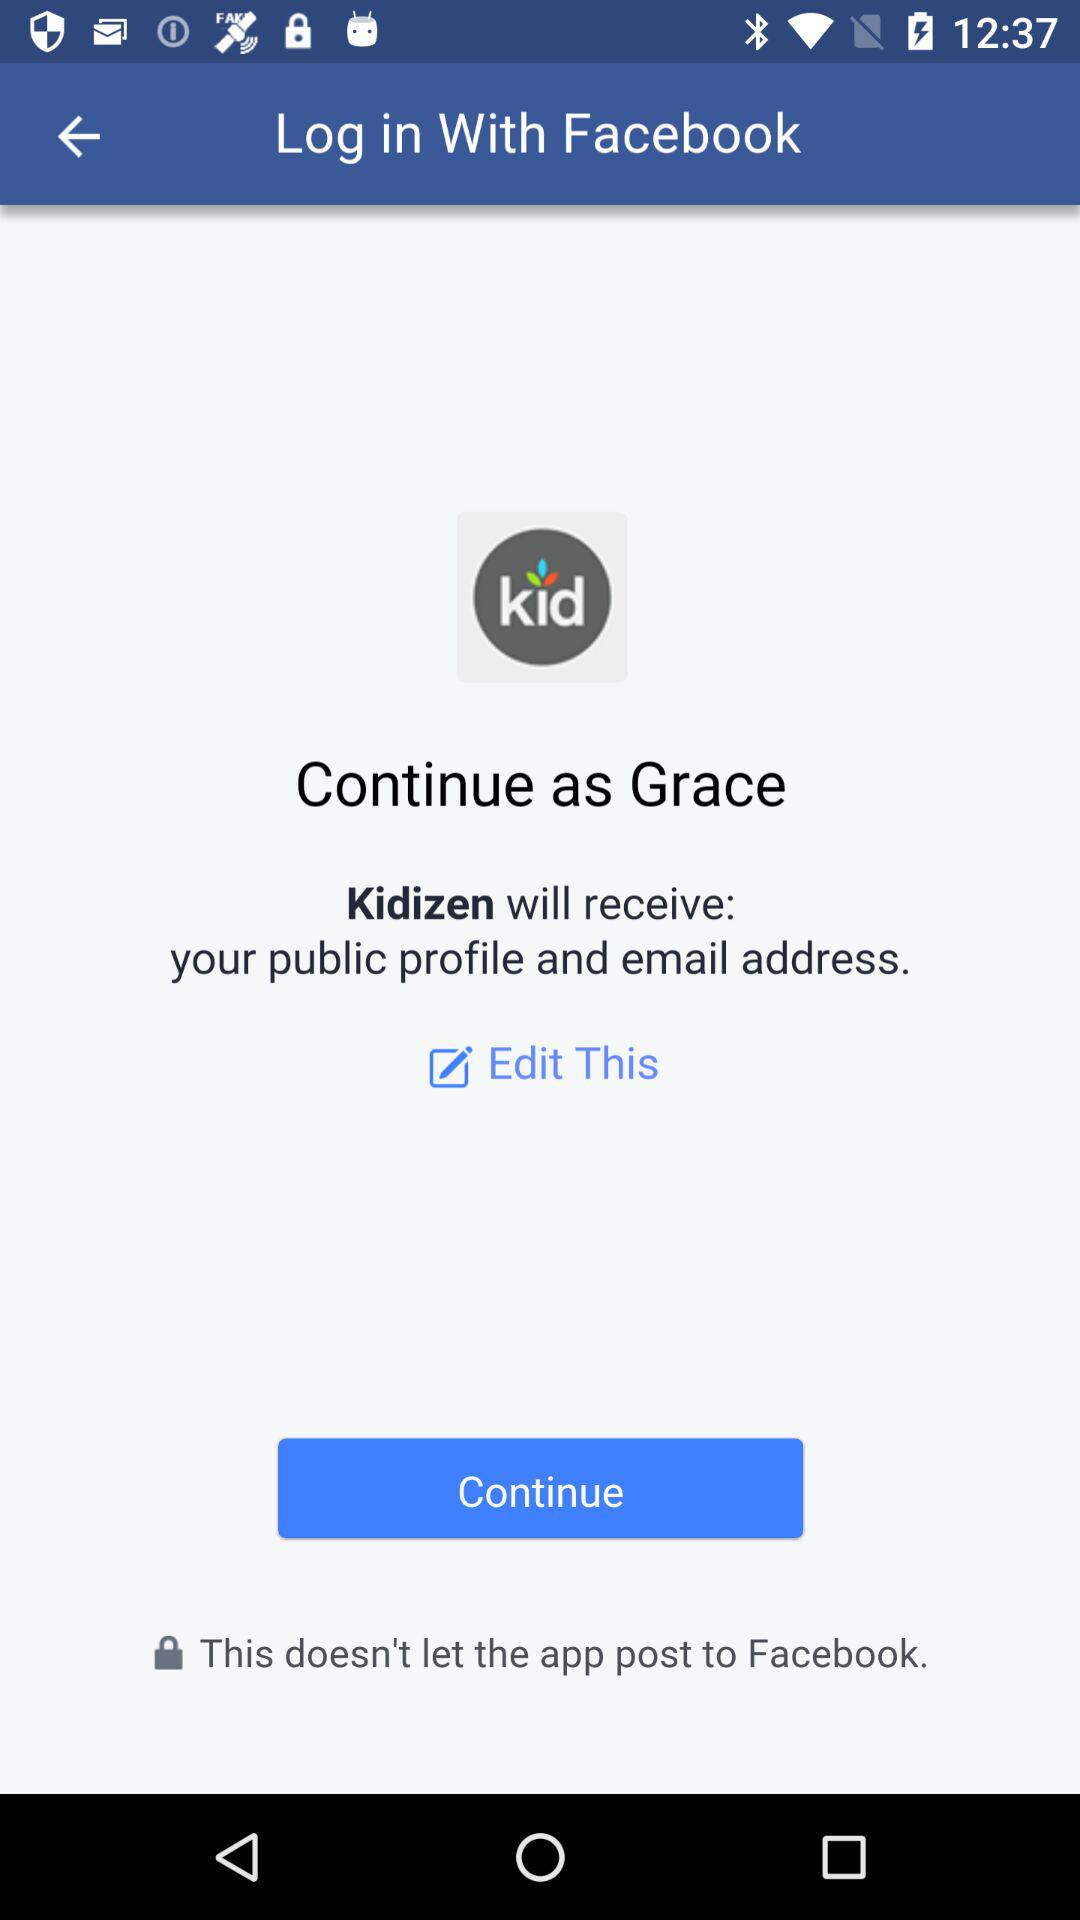Who will receive the public profile and email address? The application "Kidizen" will receive the public profile and email address. 